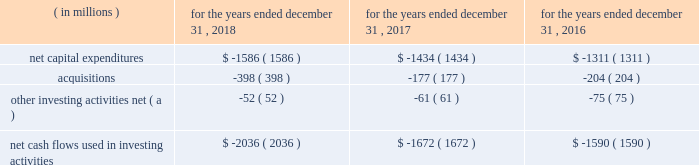In 2017 , cash flows provided by operations increased $ 160 million , primarily due to an increase in net income after non-cash adjustments , including the impact of the enactment of the tcja , and an increase in cash flows from working capital .
The main factors contributing to the net income increase are described in the 201cconsolidated results of operations 201d section and include higher operating revenues , partially offset by higher income taxes due to a $ 125 million re-measurement charge resulting from the impact of the change in the federal tax rate on the company 2019s deferred income taxes from the enactment of the tcja .
The increase in non-cash activities was mainly attributable to the increase in deferred income taxes , as mentioned above , and an increase in depreciation and amortization due to additional utility plant placed in service .
The change in working capital was principally due to ( i ) the timing of accounts payable and accrued liabilities , including the accrual recorded during 2016 for the binding global agreement in principle to settle claims associated with the freedom industries chemical spill in west virginia , ( ii ) a decrease in unbilled revenues as a result of our military services group achieving significant capital project milestones during 2016 , and ( iii ) a change in other current assets and liabilities , including the decrease in other current assets associated with the termination of our four forward starting swap agreements and timing of payments clearing our cash accounts .
The company expects to make pension contributions to the plan trusts of up to $ 31 million in 2019 .
In addition , we estimate that contributions will amount to $ 32 million , $ 29 million , $ 29 million and $ 29 million in 2020 , 2021 , 2022 and 2023 , respectively .
Actual amounts contributed could change materially from these estimates as a result of changes in assumptions and actual investment returns , among other factors .
Cash flows used in investing activities the table provides a summary of the major items affecting our cash flows used in investing activities: .
( a ) includes removal costs from property , plant and equipment retirements and proceeds from sale of assets .
In 2018 and 2017 , cash flows used in investing activities increased primarily due to an increase in our regulated capital expenditures , principally from incremental investments associated with the replacement and renewal of our transmission and distribution infrastructure in our regulated businesses , as well as acquisitions in both our regulated businesses and market-based businesses , as discussed below .
Our infrastructure investment plan consists of both infrastructure renewal programs , where we replace infrastructure , as needed , and major capital investment projects , where we construct new water and wastewater treatment and delivery facilities to meet new customer growth and water quality regulations .
Our projected capital expenditures and other investments are subject to periodic review and revision to reflect changes in economic conditions and other factors. .
In 2018 , what percentage of cash flows used in investing activities composed of acquisitions? 
Computations: (398 / 2036)
Answer: 0.19548. 